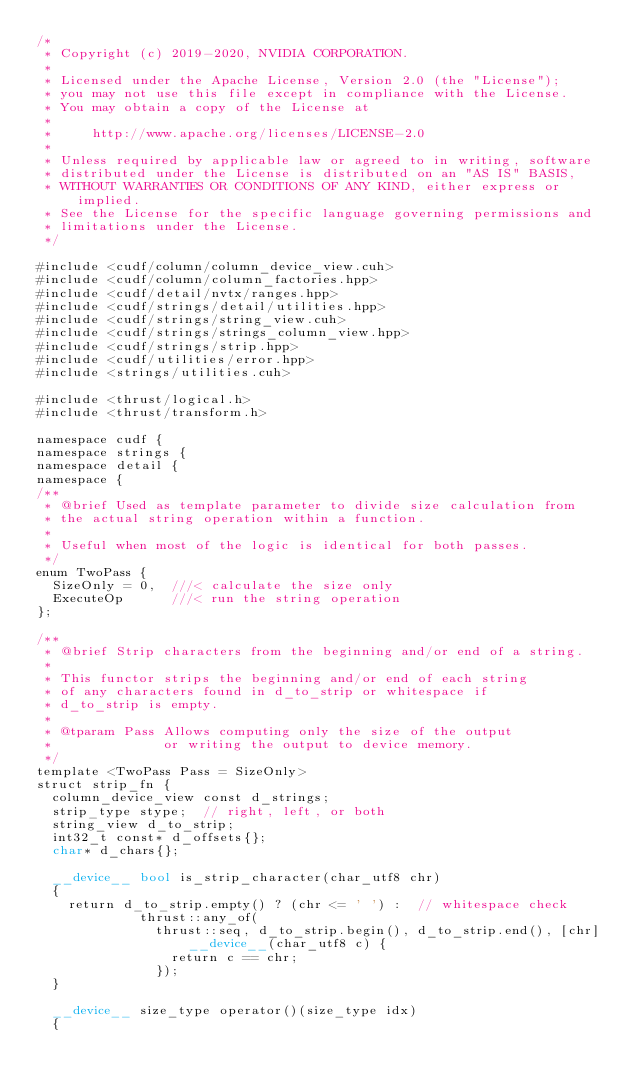<code> <loc_0><loc_0><loc_500><loc_500><_Cuda_>/*
 * Copyright (c) 2019-2020, NVIDIA CORPORATION.
 *
 * Licensed under the Apache License, Version 2.0 (the "License");
 * you may not use this file except in compliance with the License.
 * You may obtain a copy of the License at
 *
 *     http://www.apache.org/licenses/LICENSE-2.0
 *
 * Unless required by applicable law or agreed to in writing, software
 * distributed under the License is distributed on an "AS IS" BASIS,
 * WITHOUT WARRANTIES OR CONDITIONS OF ANY KIND, either express or implied.
 * See the License for the specific language governing permissions and
 * limitations under the License.
 */

#include <cudf/column/column_device_view.cuh>
#include <cudf/column/column_factories.hpp>
#include <cudf/detail/nvtx/ranges.hpp>
#include <cudf/strings/detail/utilities.hpp>
#include <cudf/strings/string_view.cuh>
#include <cudf/strings/strings_column_view.hpp>
#include <cudf/strings/strip.hpp>
#include <cudf/utilities/error.hpp>
#include <strings/utilities.cuh>

#include <thrust/logical.h>
#include <thrust/transform.h>

namespace cudf {
namespace strings {
namespace detail {
namespace {
/**
 * @brief Used as template parameter to divide size calculation from
 * the actual string operation within a function.
 *
 * Useful when most of the logic is identical for both passes.
 */
enum TwoPass {
  SizeOnly = 0,  ///< calculate the size only
  ExecuteOp      ///< run the string operation
};

/**
 * @brief Strip characters from the beginning and/or end of a string.
 *
 * This functor strips the beginning and/or end of each string
 * of any characters found in d_to_strip or whitespace if
 * d_to_strip is empty.
 *
 * @tparam Pass Allows computing only the size of the output
 *              or writing the output to device memory.
 */
template <TwoPass Pass = SizeOnly>
struct strip_fn {
  column_device_view const d_strings;
  strip_type stype;  // right, left, or both
  string_view d_to_strip;
  int32_t const* d_offsets{};
  char* d_chars{};

  __device__ bool is_strip_character(char_utf8 chr)
  {
    return d_to_strip.empty() ? (chr <= ' ') :  // whitespace check
             thrust::any_of(
               thrust::seq, d_to_strip.begin(), d_to_strip.end(), [chr] __device__(char_utf8 c) {
                 return c == chr;
               });
  }

  __device__ size_type operator()(size_type idx)
  {</code> 